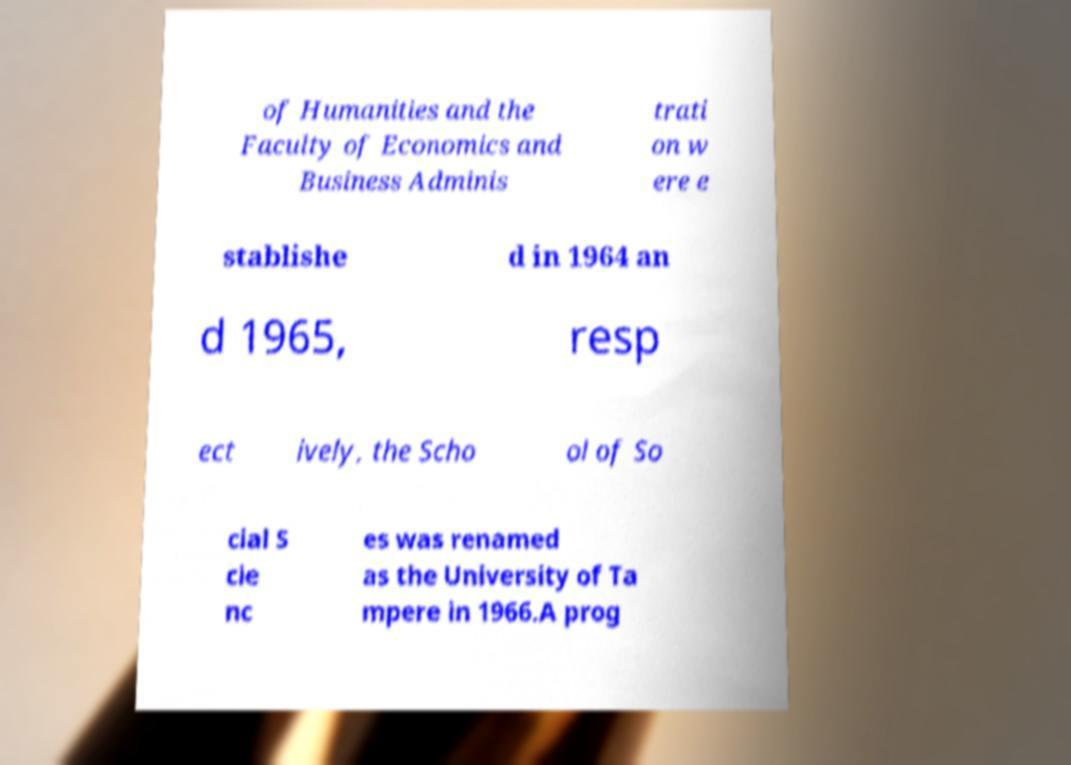Can you read and provide the text displayed in the image?This photo seems to have some interesting text. Can you extract and type it out for me? of Humanities and the Faculty of Economics and Business Adminis trati on w ere e stablishe d in 1964 an d 1965, resp ect ively, the Scho ol of So cial S cie nc es was renamed as the University of Ta mpere in 1966.A prog 